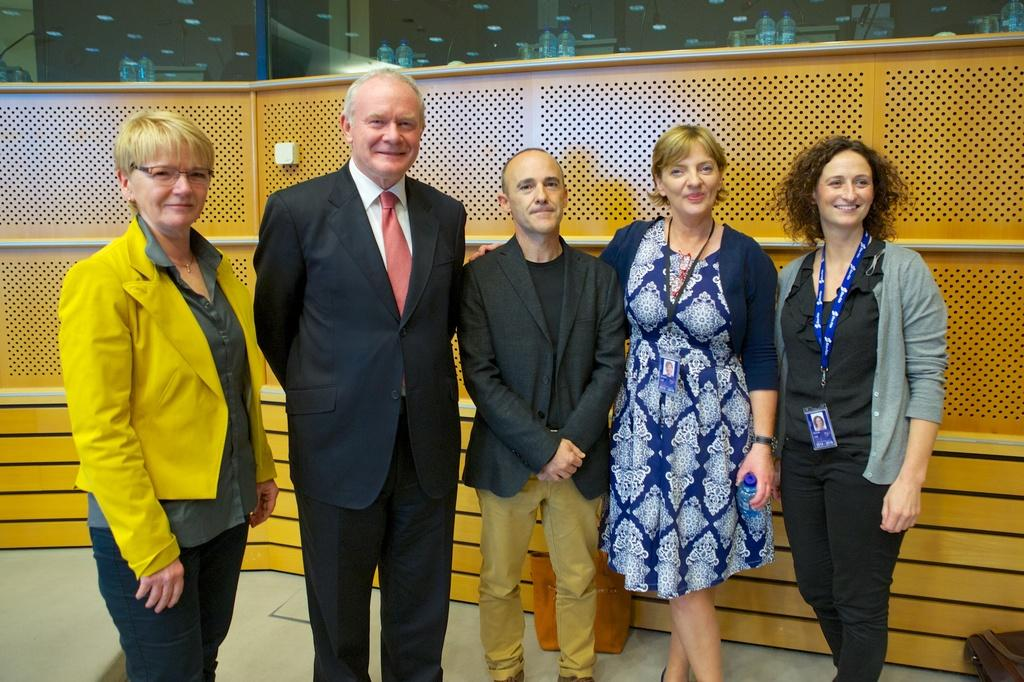Who or what is present in the image? There are people in the image. What is the facial expression of the people in the image? The people are smiling. What type of wall can be seen in the image? There is a wooden wall in the image. What is visible behind the wooden wall? There is a glass visible behind the wooden wall. What type of feast is being prepared in the image? There is no indication of a feast or any food preparation in the image. Can you tell me how many faucets are visible in the image? There are no faucets present in the image. 